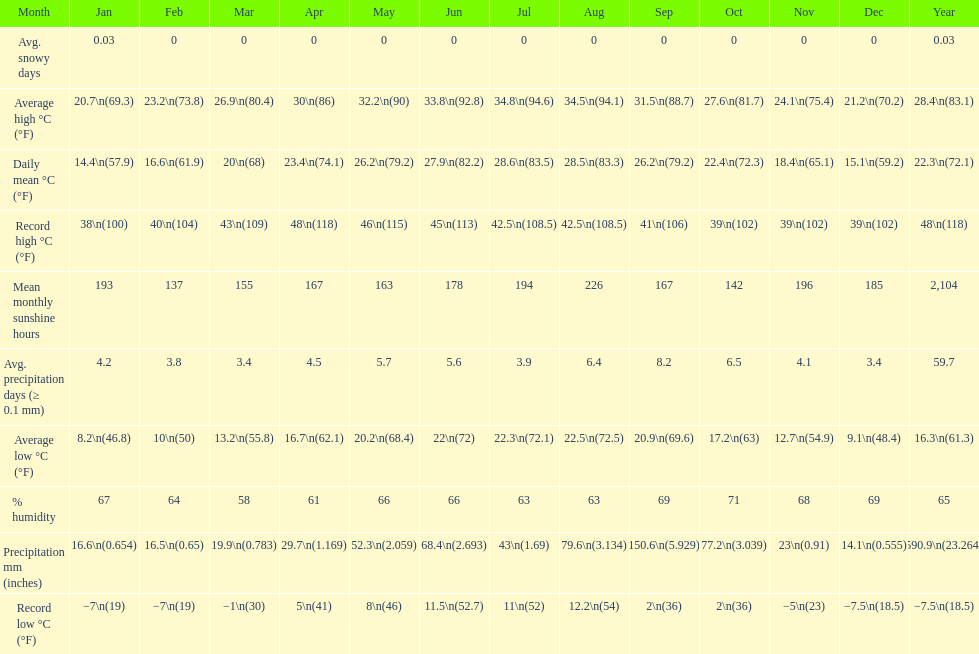Does december or january have more snow days? January. 